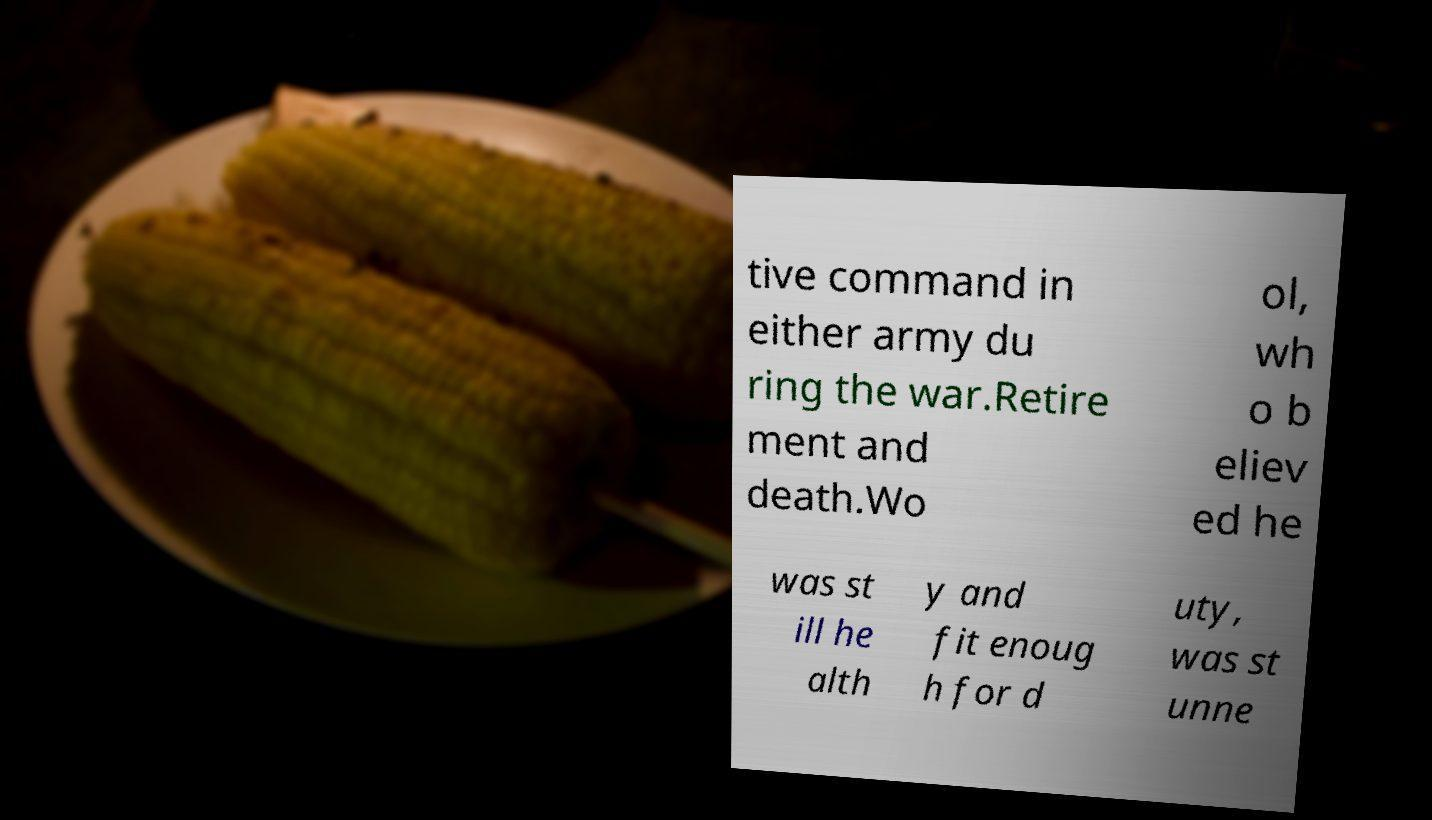Could you extract and type out the text from this image? tive command in either army du ring the war.Retire ment and death.Wo ol, wh o b eliev ed he was st ill he alth y and fit enoug h for d uty, was st unne 